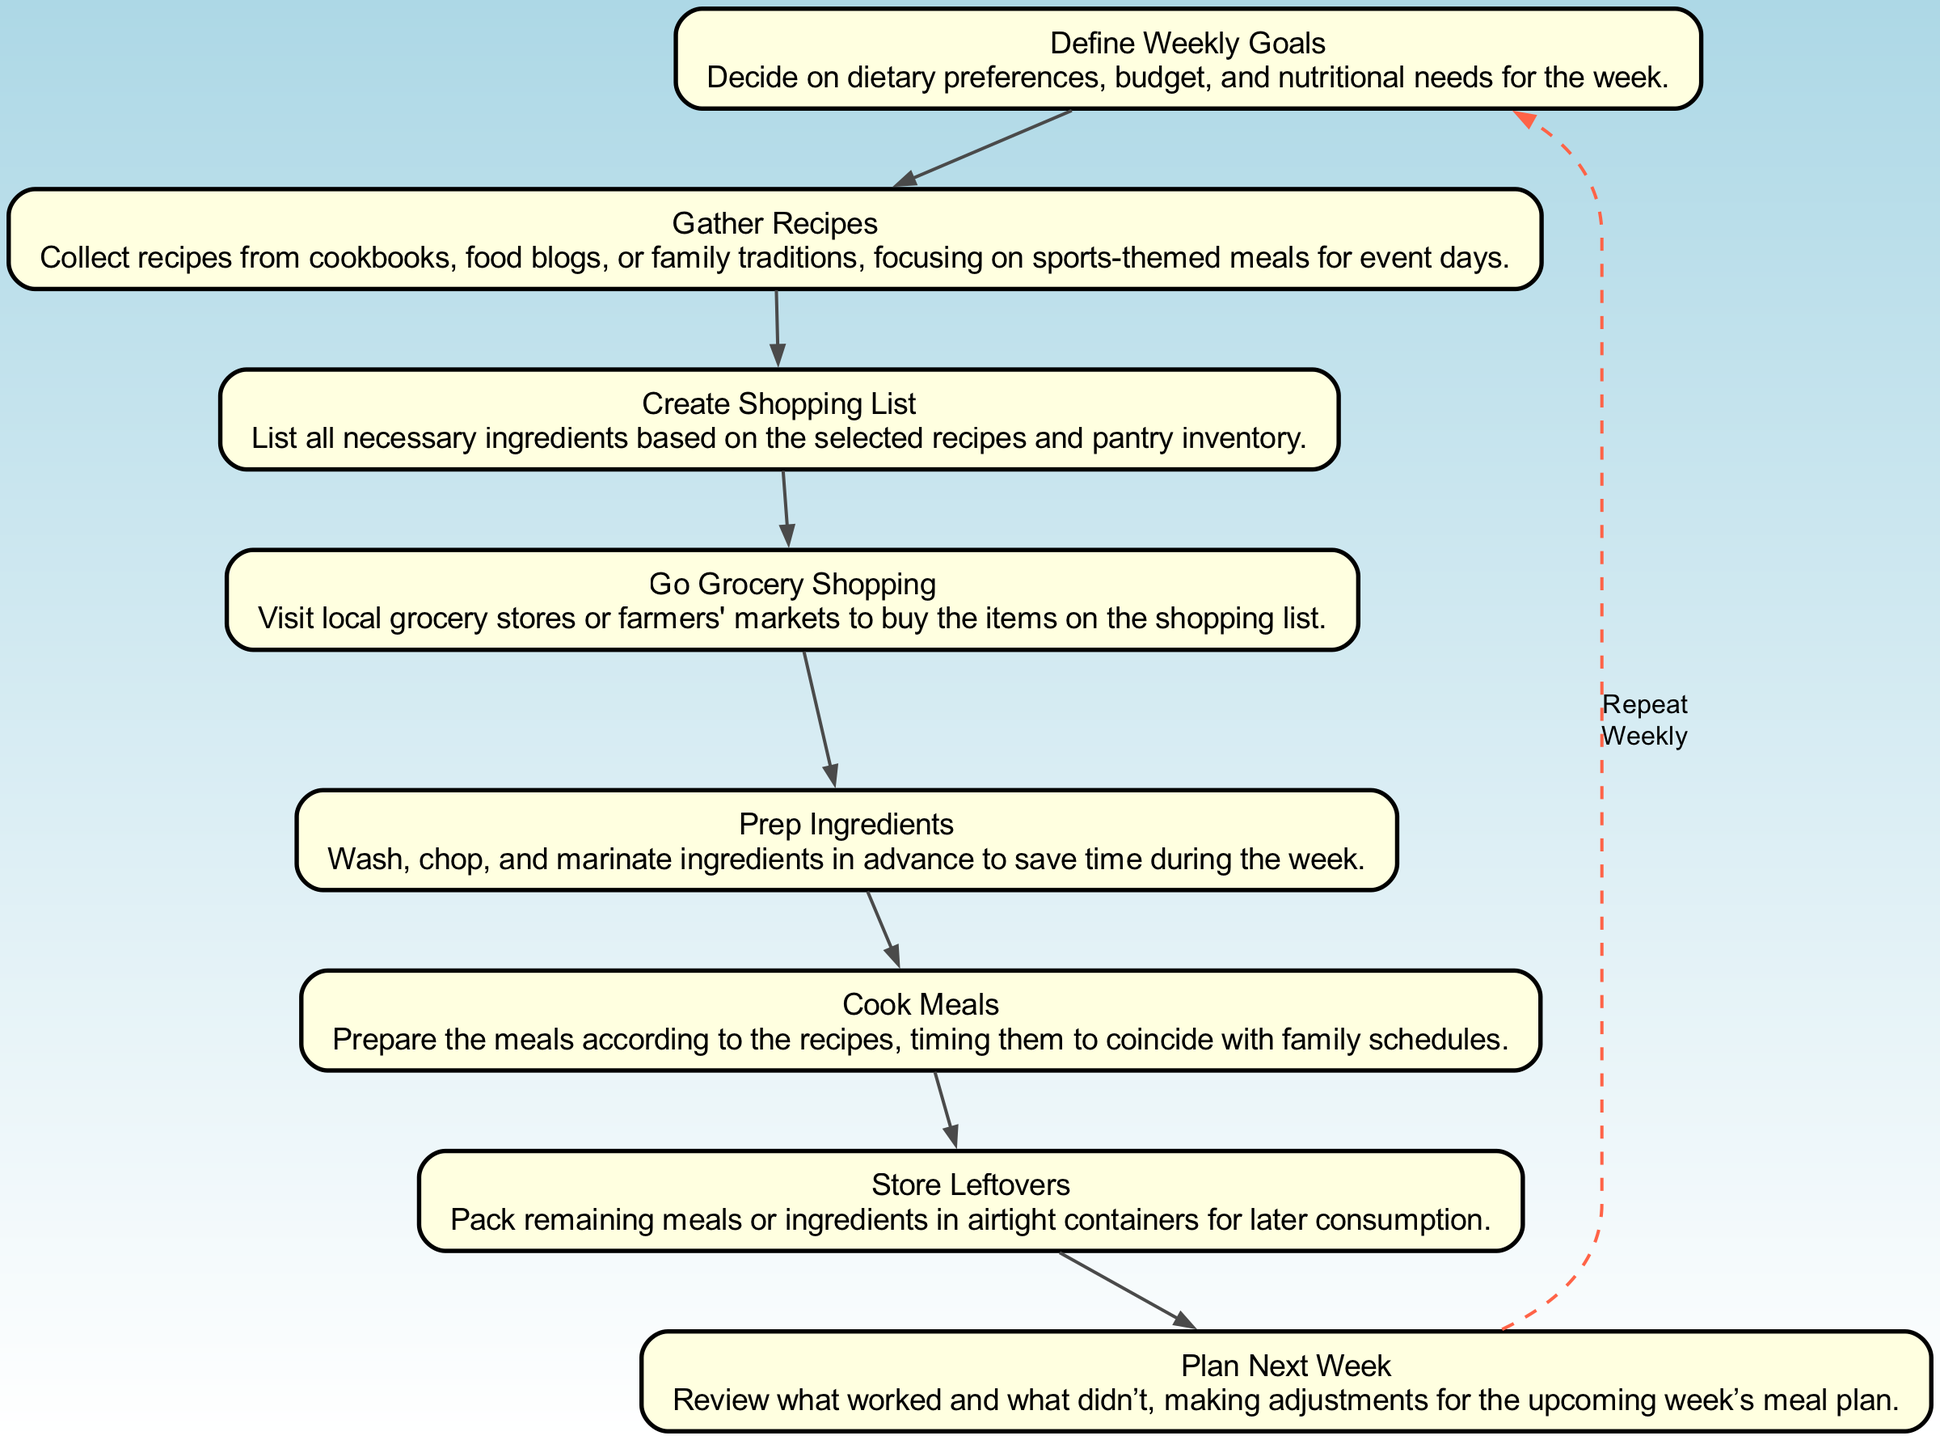What is the first step in the meal planning process? The diagram starts with the node labeled "Define Weekly Goals," indicating it as the initial step in the process.
Answer: Define Weekly Goals How many nodes are there in the flow chart? By counting the nodes listed in the data, there are a total of eight distinct steps represented in the flow chart.
Answer: Eight What is the last step before planning next week? The final step before "Plan Next Week" is "Store Leftovers," as shown in the order of steps depicted in the flow chart.
Answer: Store Leftovers Which step involves reviewing the previous week's meal plan? The step "Plan Next Week" specifically mentions reviewing what worked and what didn't, thus it includes the review process.
Answer: Plan Next Week What ingredient preparation is done before cooking meals? The step named "Prep Ingredients" describes the washing, chopping, and marinating of ingredients before cooking, highlighting this essential preparation.
Answer: Prep Ingredients What action follows the creation of a shopping list? The flow chart indicates that after "Create Shopping List," the next action is "Go Grocery Shopping," directly relating the two steps in the process.
Answer: Go Grocery Shopping Which steps are connected by a dashed edge? The dashed edge in the diagram connects "Store Leftovers" back to "Define Weekly Goals," indicating the cyclical nature of the meal planning process.
Answer: Store Leftovers to Define Weekly Goals What do you do after cooking meals? After the step of cooking meals, the next action detailed in the diagram is "Store Leftovers," emphasizing the sequence in the meal preparation plan.
Answer: Store Leftovers 